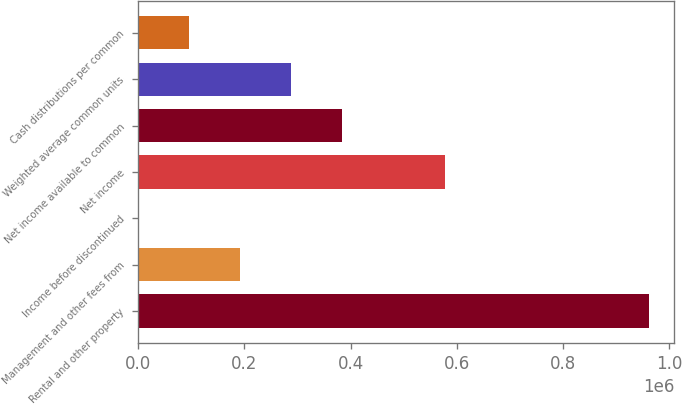Convert chart to OTSL. <chart><loc_0><loc_0><loc_500><loc_500><bar_chart><fcel>Rental and other property<fcel>Management and other fees from<fcel>Income before discontinued<fcel>Net income<fcel>Net income available to common<fcel>Weighted average common units<fcel>Cash distributions per common<nl><fcel>961591<fcel>192320<fcel>2.07<fcel>576955<fcel>384638<fcel>288479<fcel>96161<nl></chart> 